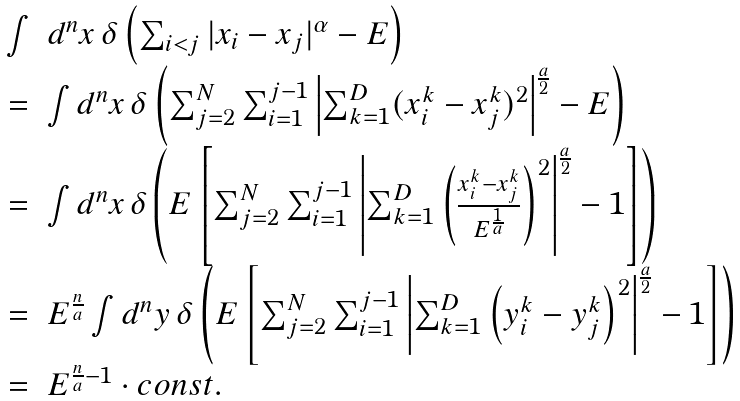Convert formula to latex. <formula><loc_0><loc_0><loc_500><loc_500>\begin{array} { l c l } & \int & d ^ { n } x \, \delta \left ( \sum _ { i < j } | x _ { i } - x _ { j } | ^ { \alpha } - E \right ) \\ & = & \int d ^ { n } x \, \delta \left ( \sum _ { j = 2 } ^ { N } \sum _ { i = 1 } ^ { j - 1 } \left | \sum _ { k = 1 } ^ { D } ( x _ { i } ^ { k } - x _ { j } ^ { k } ) ^ { 2 } \right | ^ { \frac { a } { 2 } } - E \right ) \\ & = & \int d ^ { n } x \, \delta \left ( E \left [ \sum _ { j = 2 } ^ { N } \sum _ { i = 1 } ^ { j - 1 } \left | \sum _ { k = 1 } ^ { D } \left ( \frac { x _ { i } ^ { k } - x _ { j } ^ { k } } { E ^ { \frac { 1 } { a } } } \right ) ^ { 2 } \right | ^ { \frac { a } { 2 } } - 1 \right ] \right ) \\ & = & E ^ { \frac { n } { a } } \int d ^ { n } y \, \delta \left ( E \left [ \sum _ { j = 2 } ^ { N } \sum _ { i = 1 } ^ { j - 1 } \left | \sum _ { k = 1 } ^ { D } \left ( y _ { i } ^ { k } - y _ { j } ^ { k } \right ) ^ { 2 } \right | ^ { \frac { a } { 2 } } - 1 \right ] \right ) \\ & = & E ^ { \frac { n } { a } - 1 } \cdot c o n s t . \end{array}</formula> 